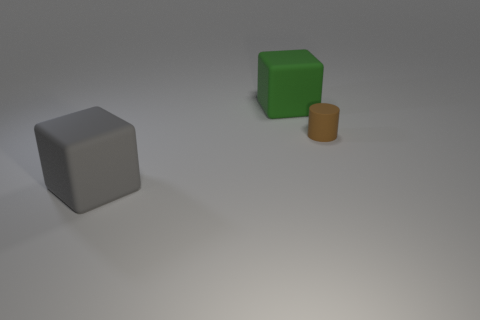Add 2 yellow rubber blocks. How many objects exist? 5 Subtract all cylinders. How many objects are left? 2 Add 2 big green matte blocks. How many big green matte blocks exist? 3 Subtract 1 gray blocks. How many objects are left? 2 Subtract all big blocks. Subtract all tiny brown cylinders. How many objects are left? 0 Add 1 green things. How many green things are left? 2 